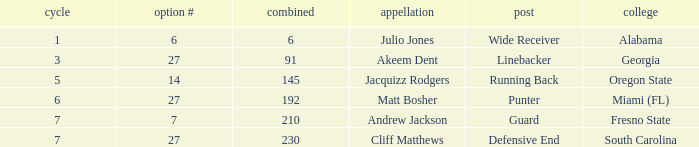Which appellation had in excess of 5 rounds and was a defensive end? Cliff Matthews. 